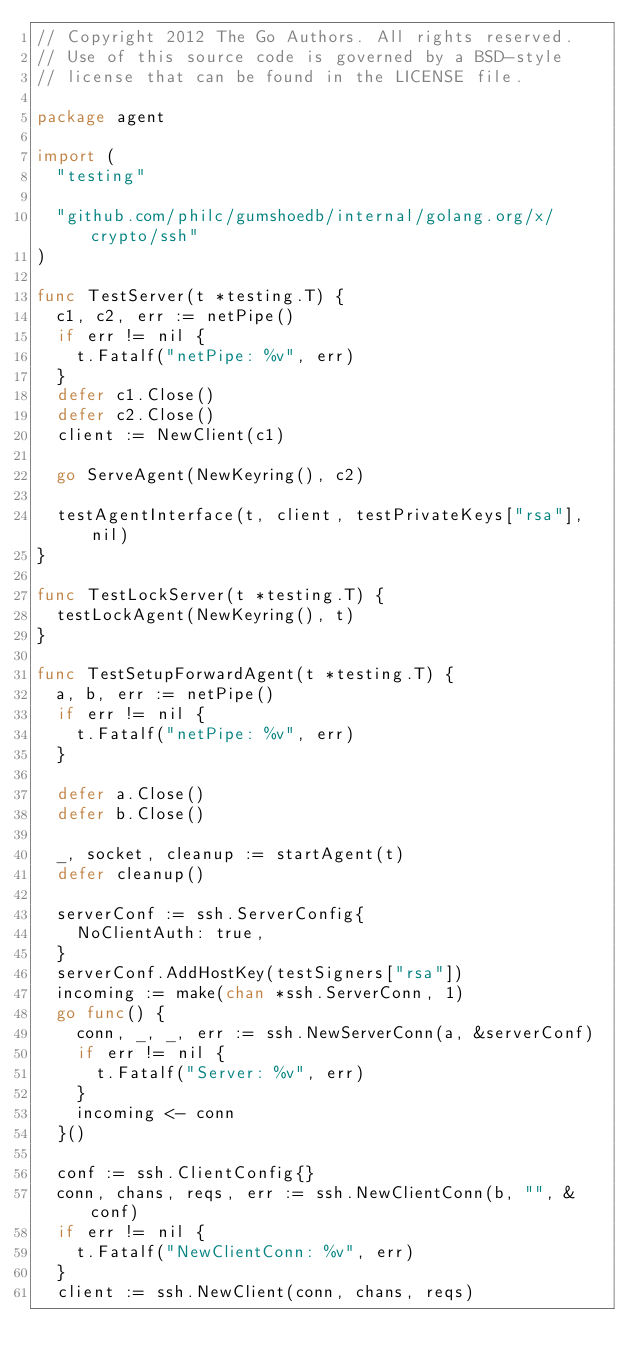Convert code to text. <code><loc_0><loc_0><loc_500><loc_500><_Go_>// Copyright 2012 The Go Authors. All rights reserved.
// Use of this source code is governed by a BSD-style
// license that can be found in the LICENSE file.

package agent

import (
	"testing"

	"github.com/philc/gumshoedb/internal/golang.org/x/crypto/ssh"
)

func TestServer(t *testing.T) {
	c1, c2, err := netPipe()
	if err != nil {
		t.Fatalf("netPipe: %v", err)
	}
	defer c1.Close()
	defer c2.Close()
	client := NewClient(c1)

	go ServeAgent(NewKeyring(), c2)

	testAgentInterface(t, client, testPrivateKeys["rsa"], nil)
}

func TestLockServer(t *testing.T) {
	testLockAgent(NewKeyring(), t)
}

func TestSetupForwardAgent(t *testing.T) {
	a, b, err := netPipe()
	if err != nil {
		t.Fatalf("netPipe: %v", err)
	}

	defer a.Close()
	defer b.Close()

	_, socket, cleanup := startAgent(t)
	defer cleanup()

	serverConf := ssh.ServerConfig{
		NoClientAuth: true,
	}
	serverConf.AddHostKey(testSigners["rsa"])
	incoming := make(chan *ssh.ServerConn, 1)
	go func() {
		conn, _, _, err := ssh.NewServerConn(a, &serverConf)
		if err != nil {
			t.Fatalf("Server: %v", err)
		}
		incoming <- conn
	}()

	conf := ssh.ClientConfig{}
	conn, chans, reqs, err := ssh.NewClientConn(b, "", &conf)
	if err != nil {
		t.Fatalf("NewClientConn: %v", err)
	}
	client := ssh.NewClient(conn, chans, reqs)
</code> 